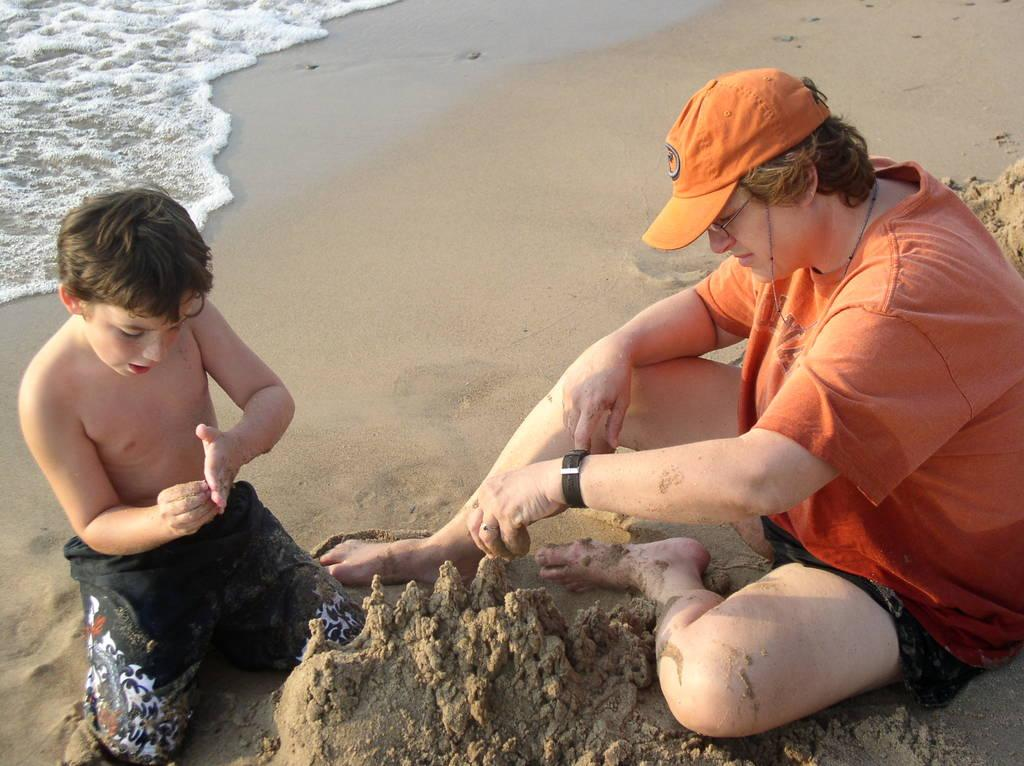Who is present in the image? There is a person and a kid in the image. What are the person and the kid doing in the image? Both the person and the kid are playing with sand. Where is the location of the image? The location is near the sea shore. What can be seen in the top left corner of the image? Water is visible in the top left corner of the image. What type of brick is being used to build a structure in the image? There is no structure or brick present in the image; it is near the sea shore. 